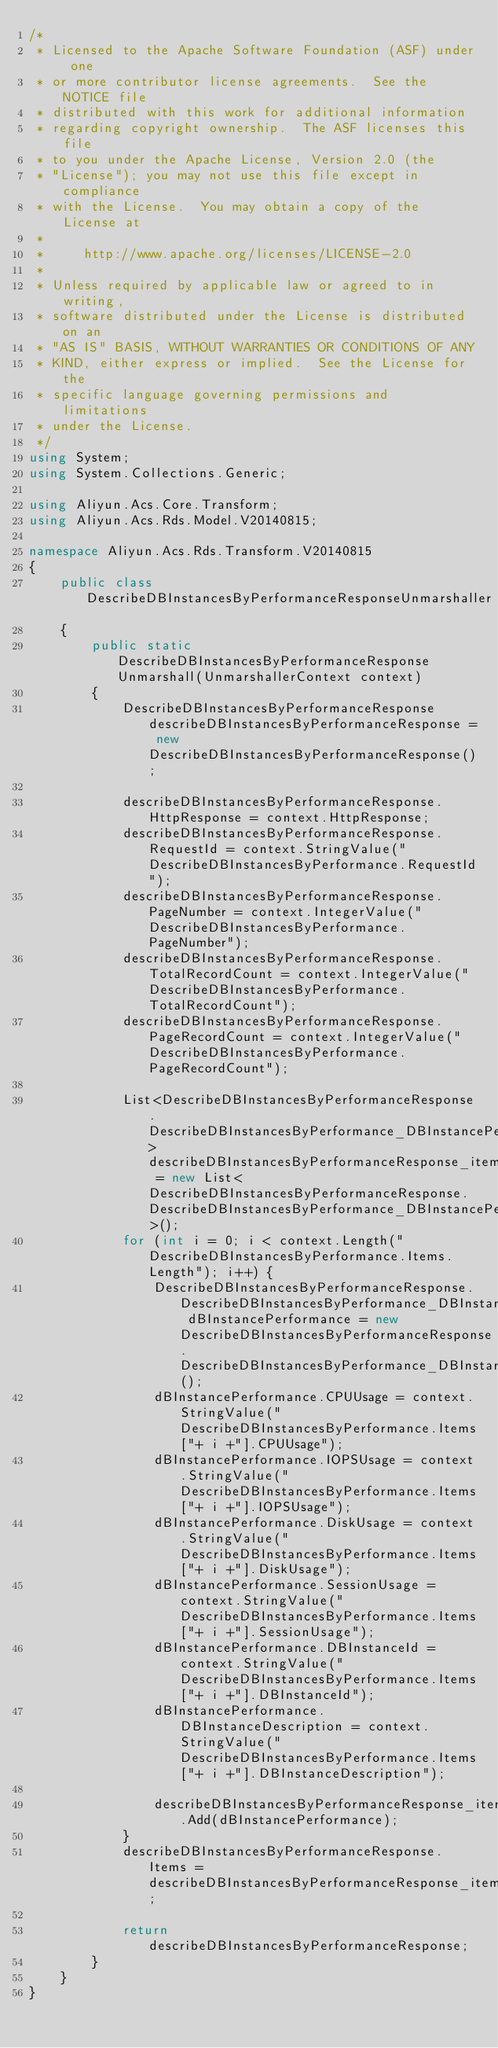<code> <loc_0><loc_0><loc_500><loc_500><_C#_>/*
 * Licensed to the Apache Software Foundation (ASF) under one
 * or more contributor license agreements.  See the NOTICE file
 * distributed with this work for additional information
 * regarding copyright ownership.  The ASF licenses this file
 * to you under the Apache License, Version 2.0 (the
 * "License"); you may not use this file except in compliance
 * with the License.  You may obtain a copy of the License at
 *
 *     http://www.apache.org/licenses/LICENSE-2.0
 *
 * Unless required by applicable law or agreed to in writing,
 * software distributed under the License is distributed on an
 * "AS IS" BASIS, WITHOUT WARRANTIES OR CONDITIONS OF ANY
 * KIND, either express or implied.  See the License for the
 * specific language governing permissions and limitations
 * under the License.
 */
using System;
using System.Collections.Generic;

using Aliyun.Acs.Core.Transform;
using Aliyun.Acs.Rds.Model.V20140815;

namespace Aliyun.Acs.Rds.Transform.V20140815
{
    public class DescribeDBInstancesByPerformanceResponseUnmarshaller
    {
        public static DescribeDBInstancesByPerformanceResponse Unmarshall(UnmarshallerContext context)
        {
			DescribeDBInstancesByPerformanceResponse describeDBInstancesByPerformanceResponse = new DescribeDBInstancesByPerformanceResponse();

			describeDBInstancesByPerformanceResponse.HttpResponse = context.HttpResponse;
			describeDBInstancesByPerformanceResponse.RequestId = context.StringValue("DescribeDBInstancesByPerformance.RequestId");
			describeDBInstancesByPerformanceResponse.PageNumber = context.IntegerValue("DescribeDBInstancesByPerformance.PageNumber");
			describeDBInstancesByPerformanceResponse.TotalRecordCount = context.IntegerValue("DescribeDBInstancesByPerformance.TotalRecordCount");
			describeDBInstancesByPerformanceResponse.PageRecordCount = context.IntegerValue("DescribeDBInstancesByPerformance.PageRecordCount");

			List<DescribeDBInstancesByPerformanceResponse.DescribeDBInstancesByPerformance_DBInstancePerformance> describeDBInstancesByPerformanceResponse_items = new List<DescribeDBInstancesByPerformanceResponse.DescribeDBInstancesByPerformance_DBInstancePerformance>();
			for (int i = 0; i < context.Length("DescribeDBInstancesByPerformance.Items.Length"); i++) {
				DescribeDBInstancesByPerformanceResponse.DescribeDBInstancesByPerformance_DBInstancePerformance dBInstancePerformance = new DescribeDBInstancesByPerformanceResponse.DescribeDBInstancesByPerformance_DBInstancePerformance();
				dBInstancePerformance.CPUUsage = context.StringValue("DescribeDBInstancesByPerformance.Items["+ i +"].CPUUsage");
				dBInstancePerformance.IOPSUsage = context.StringValue("DescribeDBInstancesByPerformance.Items["+ i +"].IOPSUsage");
				dBInstancePerformance.DiskUsage = context.StringValue("DescribeDBInstancesByPerformance.Items["+ i +"].DiskUsage");
				dBInstancePerformance.SessionUsage = context.StringValue("DescribeDBInstancesByPerformance.Items["+ i +"].SessionUsage");
				dBInstancePerformance.DBInstanceId = context.StringValue("DescribeDBInstancesByPerformance.Items["+ i +"].DBInstanceId");
				dBInstancePerformance.DBInstanceDescription = context.StringValue("DescribeDBInstancesByPerformance.Items["+ i +"].DBInstanceDescription");

				describeDBInstancesByPerformanceResponse_items.Add(dBInstancePerformance);
			}
			describeDBInstancesByPerformanceResponse.Items = describeDBInstancesByPerformanceResponse_items;
        
			return describeDBInstancesByPerformanceResponse;
        }
    }
}
</code> 